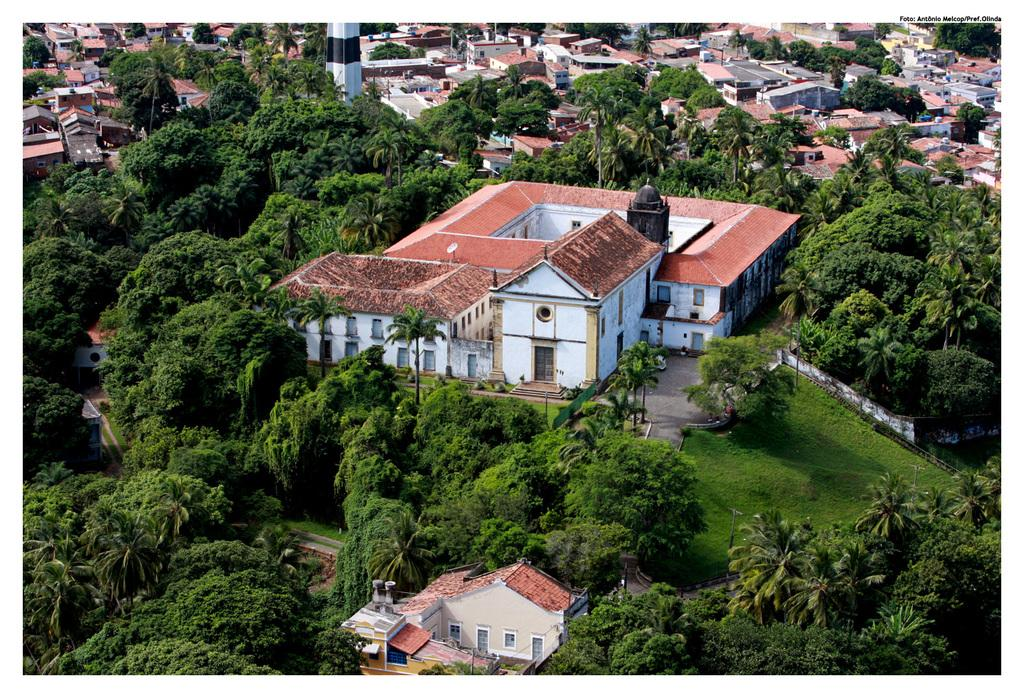What perspective is the image taken from? The image is taken from a top view. What types of structures can be seen in the image? There are buildings and houses in the image. What natural elements are present in the image? There are trees and grass on a hill in the center of the image. What type of party is happening in the image? There is no party present in the image; it shows a top view of buildings, houses, trees, and grass on a hill. Can you hear a whistle in the image? There is no auditory information in the image, as it is a still photograph. 